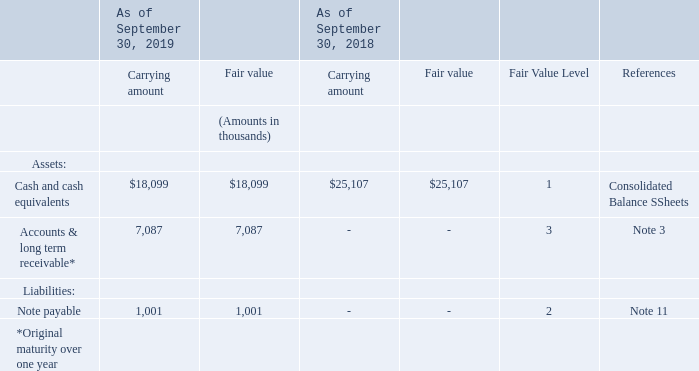Fair Value Disclosures
Under the fair value standards fair value is based on the exit price and defined as the price that would be received to sell an asset or transfer a liability in an orderly transaction between market participants at the measurement date. The fair value measurement should reflect all the assumptions that market participants would use in pricing an asset or liability. A fair value hierarchy is established in the authoritative guidance outlined in three levels ranking from Level 1 to level 3 with Level 1 being the highest priority.
Level 1: observable inputs that reflect quoted prices (unadjusted) for identical assets or liabilities in active markets
Level 2: inputs other than quoted prices included in Level 1 that are observable for the asset or liability either directly or indirectly
Level 3: unobservable inputs (e.g., a reporting entity’s or other entity’s own data)
The Company had no assets or liabilities measured at fair value on a recurring (except our pension plan assets, see Note 15) or
non-recurring basis as of September 30, 2019 or September 30, 2018.
To estimate fair value of the financial instruments below quoted market prices are used when available and classified within Level 1. If this data is not available, we use observable market based inputs to estimate fair value, which are classified within Level 2. If the preceding information is unavailable, we use internally generated data to estimate fair value which is classified within Level 3.
Cash and cash equivalents
Carrying amount approximated fair value
Accounts and long term receivable with original maturity over one year
Fair value was estimated by discounting future cash flows based on the current rate with similar terms.
Note payable
Fair value was estimated based on quoted market prices.
Fair value of accounts receivable with an original maturity of one year or less and accounts payable was not materially different from their carrying values at September 30, 2019, and 2018.
What does a Level 1 fair value hierarchy refer to? Observable inputs that reflect quoted prices (unadjusted) for identical assets or liabilities in active markets. What does a Level 3 fair value hierarchy refer to? Unobservable inputs (e.g., a reporting entity’s or other entity’s own data). How is the fair value for note payable determined?  Inputs other than quoted prices included in level 1 that are observable for the asset or liability either directly or indirectly. What is the difference in fair value of cash and cash equivalents between 2018 and 2019?
Answer scale should be: thousand. 18,099 - 25,107 
Answer: -7008. What is the difference in the carrying amount and fair value of the accounts & long term receivable in 2019? 
Answer scale should be: thousand. 7,087 - 7,087 
Answer: 0. What is the percentage change in the fair value of cash and cash equivalents between 2018 and 2019?
Answer scale should be: percent. (18,099 - 25,107)/25,107 
Answer: -27.91. 